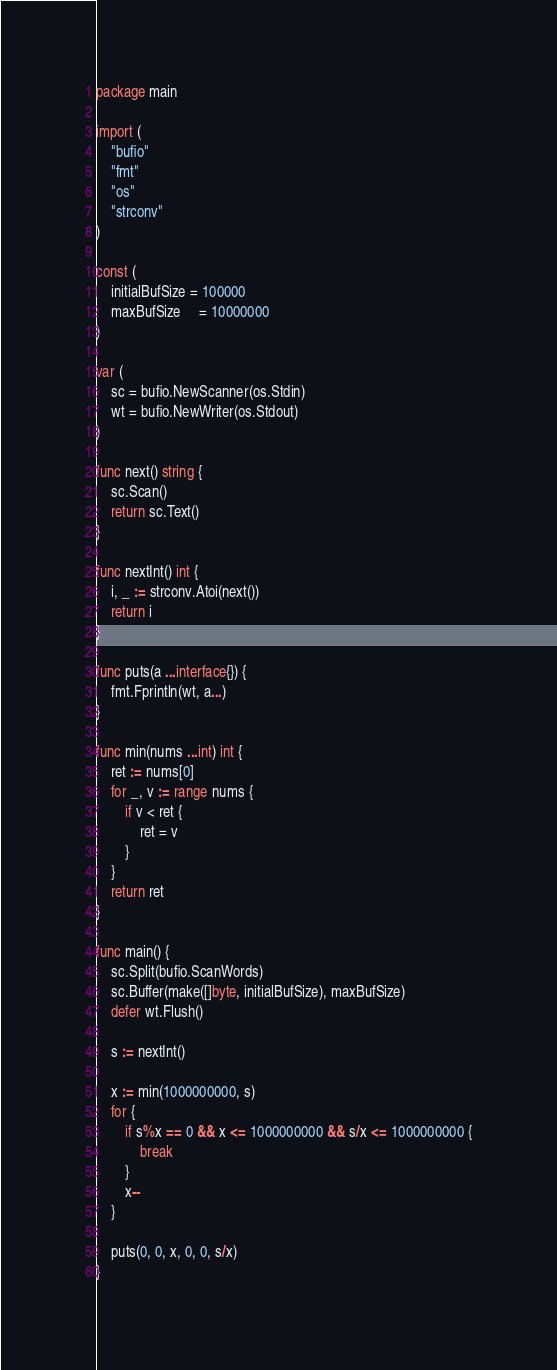<code> <loc_0><loc_0><loc_500><loc_500><_Go_>package main

import (
	"bufio"
	"fmt"
	"os"
	"strconv"
)

const (
	initialBufSize = 100000
	maxBufSize     = 10000000
)

var (
	sc = bufio.NewScanner(os.Stdin)
	wt = bufio.NewWriter(os.Stdout)
)

func next() string {
	sc.Scan()
	return sc.Text()
}

func nextInt() int {
	i, _ := strconv.Atoi(next())
	return i
}

func puts(a ...interface{}) {
	fmt.Fprintln(wt, a...)
}

func min(nums ...int) int {
	ret := nums[0]
	for _, v := range nums {
		if v < ret {
			ret = v
		}
	}
	return ret
}

func main() {
	sc.Split(bufio.ScanWords)
	sc.Buffer(make([]byte, initialBufSize), maxBufSize)
	defer wt.Flush()

	s := nextInt()

	x := min(1000000000, s)
	for {
		if s%x == 0 && x <= 1000000000 && s/x <= 1000000000 {
			break
		}
		x--
	}

	puts(0, 0, x, 0, 0, s/x)
}
</code> 